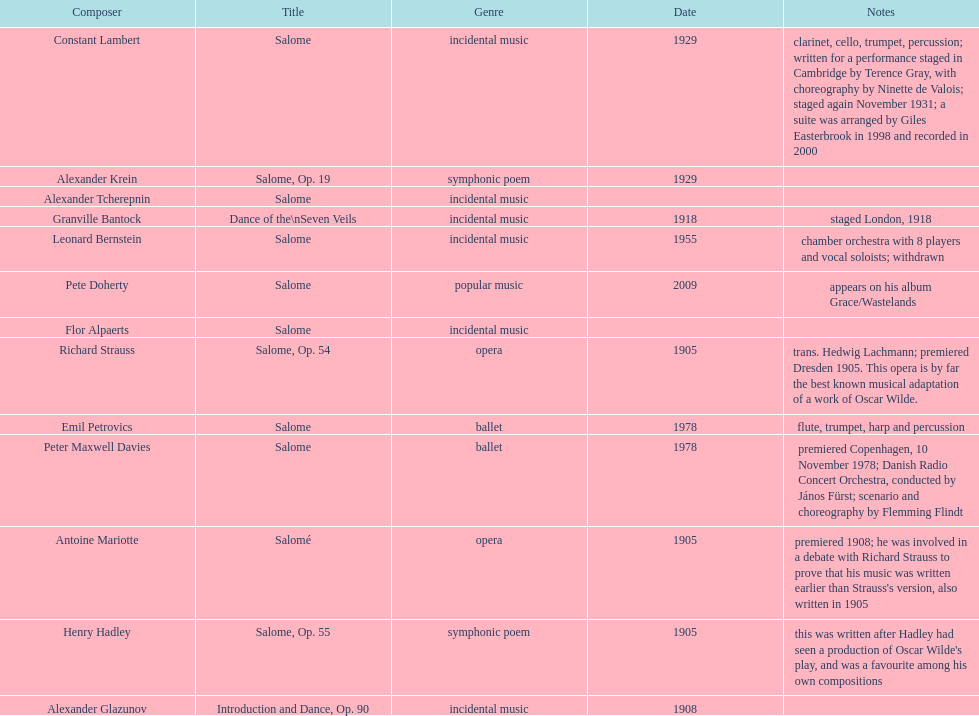What is the number of works titled "salome?" 11. Can you give me this table as a dict? {'header': ['Composer', 'Title', 'Genre', 'Date', 'Notes'], 'rows': [['Constant Lambert', 'Salome', 'incidental music', '1929', 'clarinet, cello, trumpet, percussion; written for a performance staged in Cambridge by Terence Gray, with choreography by Ninette de Valois; staged again November 1931; a suite was arranged by Giles Easterbrook in 1998 and recorded in 2000'], ['Alexander Krein', 'Salome, Op. 19', 'symphonic poem', '1929', ''], ['Alexander\xa0Tcherepnin', 'Salome', 'incidental music', '', ''], ['Granville Bantock', 'Dance of the\\nSeven Veils', 'incidental music', '1918', 'staged London, 1918'], ['Leonard Bernstein', 'Salome', 'incidental music', '1955', 'chamber orchestra with 8 players and vocal soloists; withdrawn'], ['Pete Doherty', 'Salome', 'popular music', '2009', 'appears on his album Grace/Wastelands'], ['Flor Alpaerts', 'Salome', 'incidental\xa0music', '', ''], ['Richard Strauss', 'Salome, Op. 54', 'opera', '1905', 'trans. Hedwig Lachmann; premiered Dresden 1905. This opera is by far the best known musical adaptation of a work of Oscar Wilde.'], ['Emil Petrovics', 'Salome', 'ballet', '1978', 'flute, trumpet, harp and percussion'], ['Peter\xa0Maxwell\xa0Davies', 'Salome', 'ballet', '1978', 'premiered Copenhagen, 10 November 1978; Danish Radio Concert Orchestra, conducted by János Fürst; scenario and choreography by Flemming Flindt'], ['Antoine Mariotte', 'Salomé', 'opera', '1905', "premiered 1908; he was involved in a debate with Richard Strauss to prove that his music was written earlier than Strauss's version, also written in 1905"], ['Henry Hadley', 'Salome, Op. 55', 'symphonic poem', '1905', "this was written after Hadley had seen a production of Oscar Wilde's play, and was a favourite among his own compositions"], ['Alexander Glazunov', 'Introduction and Dance, Op. 90', 'incidental music', '1908', '']]} 